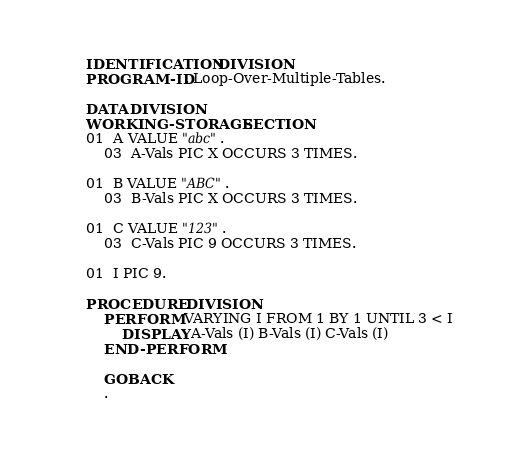<code> <loc_0><loc_0><loc_500><loc_500><_COBOL_>       IDENTIFICATION DIVISION.
       PROGRAM-ID. Loop-Over-Multiple-Tables.

       DATA DIVISION.
       WORKING-STORAGE SECTION.
       01  A VALUE "abc".
           03  A-Vals PIC X OCCURS 3 TIMES.

       01  B VALUE "ABC".
           03  B-Vals PIC X OCCURS 3 TIMES.

       01  C VALUE "123".
           03  C-Vals PIC 9 OCCURS 3 TIMES.

       01  I PIC 9.

       PROCEDURE DIVISION.
           PERFORM VARYING I FROM 1 BY 1 UNTIL 3 < I
               DISPLAY A-Vals (I) B-Vals (I) C-Vals (I)
           END-PERFORM

           GOBACK
           .
</code> 